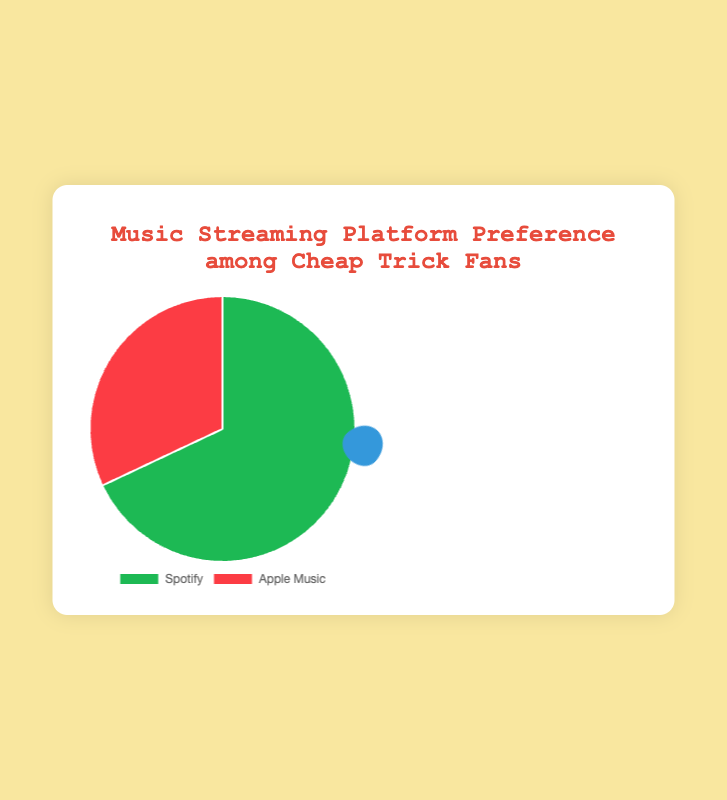What percentage of Cheap Trick fans prefer Spotify? According to the pie chart, Spotify is represented by a segment that shows 68%.
Answer: 68% What fraction of Cheap Trick fans use Apple Music? The chart shows that 32% of fans use Apple Music. To convert this percentage into a fraction, 32/100 simplifies to 8/25.
Answer: 8/25 Which music streaming platform is preferred by more Cheap Trick fans? The chart shows 68% of fans prefer Spotify and 32% prefer Apple Music. 68% is greater than 32%.
Answer: Spotify What is the difference in preference percentages between Spotify and Apple Music? Spotify accounts for 68% and Apple Music for 32%. The difference is 68 - 32 = 36.
Answer: 36% How many times larger is the percentage of Spotify users compared to Apple Music users among Cheap Trick fans? Spotify has 68% and Apple Music has 32%. The ratio is 68/32, which simplifies to 2.125 times.
Answer: 2.125 times What would the percentage be if the total preference for Spotify and Apple Music were equal among Cheap Trick fans? For equal preference, both platforms would each be 50% (100% / 2).
Answer: 50% If 1000 Cheap Trick fans were surveyed, how many would prefer Spotify? Given that 68% of fans prefer Spotify, multiply 1000 by 0.68. 1000 * 0.68 = 680.
Answer: 680 What is the overall message conveyed by the pie chart? The pie chart shows that a significant majority (68%) of Cheap Trick fans prefer Spotify over Apple Music (32%).
Answer: Majority prefer Spotify 